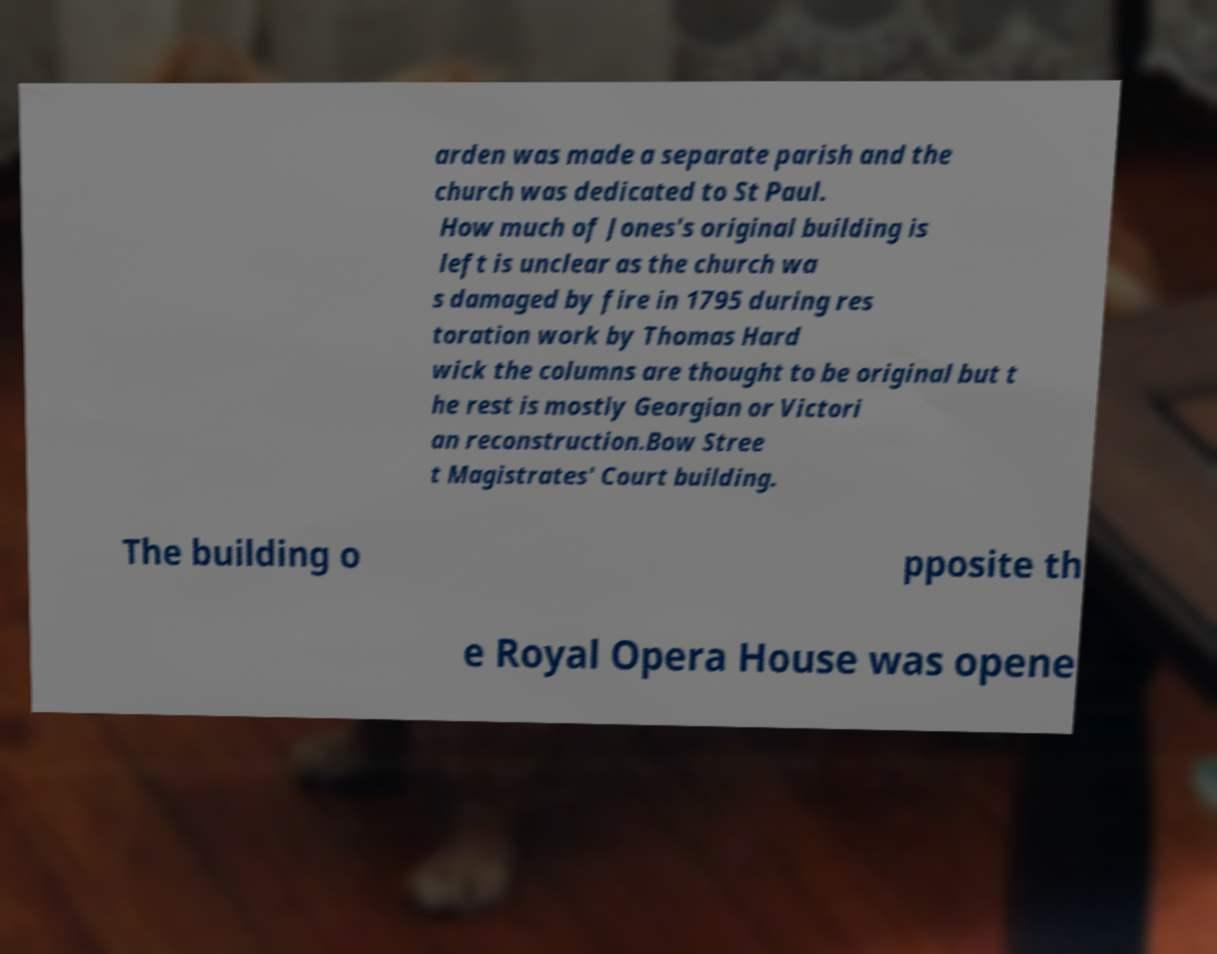Could you extract and type out the text from this image? arden was made a separate parish and the church was dedicated to St Paul. How much of Jones's original building is left is unclear as the church wa s damaged by fire in 1795 during res toration work by Thomas Hard wick the columns are thought to be original but t he rest is mostly Georgian or Victori an reconstruction.Bow Stree t Magistrates' Court building. The building o pposite th e Royal Opera House was opene 